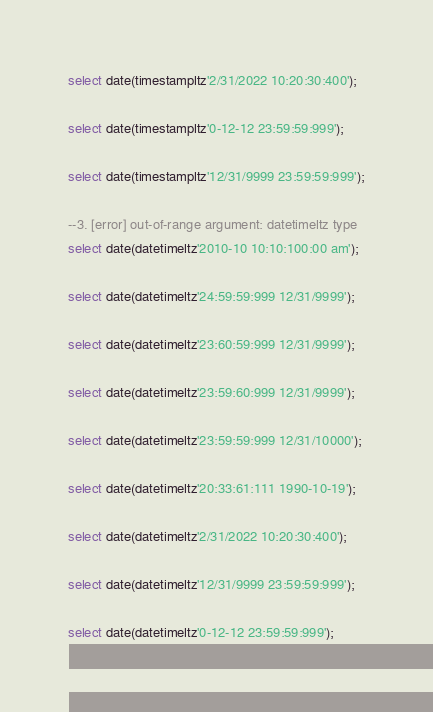<code> <loc_0><loc_0><loc_500><loc_500><_SQL_>
select date(timestampltz'2/31/2022 10:20:30:400');

select date(timestampltz'0-12-12 23:59:59:999');

select date(timestampltz'12/31/9999 23:59:59:999');

--3. [error] out-of-range argument: datetimeltz type
select date(datetimeltz'2010-10 10:10:100:00 am');

select date(datetimeltz'24:59:59:999 12/31/9999');

select date(datetimeltz'23:60:59:999 12/31/9999');

select date(datetimeltz'23:59:60:999 12/31/9999');

select date(datetimeltz'23:59:59:999 12/31/10000');

select date(datetimeltz'20:33:61:111 1990-10-19');

select date(datetimeltz'2/31/2022 10:20:30:400');

select date(datetimeltz'12/31/9999 23:59:59:999');

select date(datetimeltz'0-12-12 23:59:59:999');

</code> 